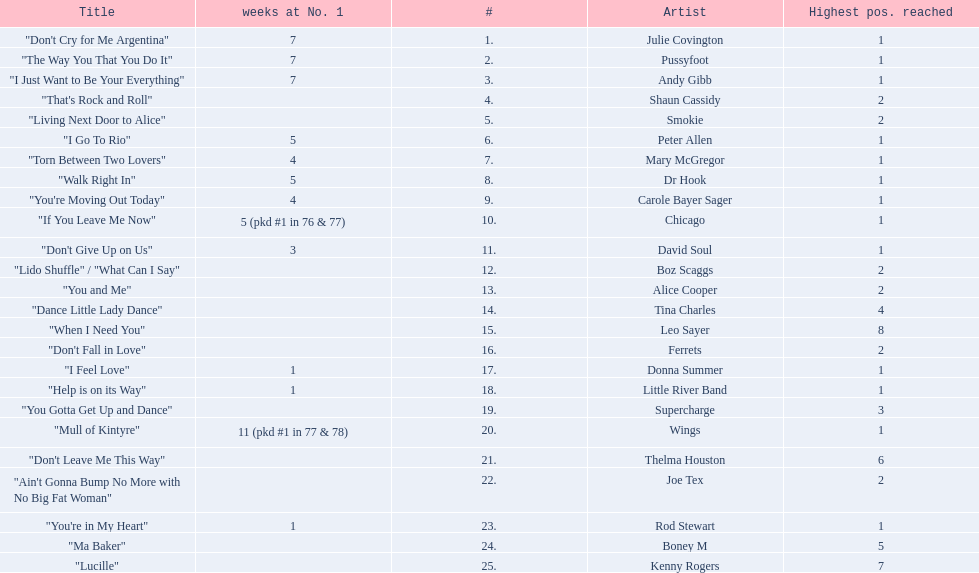Which artists were included in the top 25 singles for 1977 in australia? Julie Covington, Pussyfoot, Andy Gibb, Shaun Cassidy, Smokie, Peter Allen, Mary McGregor, Dr Hook, Carole Bayer Sager, Chicago, David Soul, Boz Scaggs, Alice Cooper, Tina Charles, Leo Sayer, Ferrets, Donna Summer, Little River Band, Supercharge, Wings, Thelma Houston, Joe Tex, Rod Stewart, Boney M, Kenny Rogers. And for how many weeks did they chart at number 1? 7, 7, 7, , , 5, 4, 5, 4, 5 (pkd #1 in 76 & 77), 3, , , , , , 1, 1, , 11 (pkd #1 in 77 & 78), , , 1, , . Which artist was in the number 1 spot for most time? Wings. 